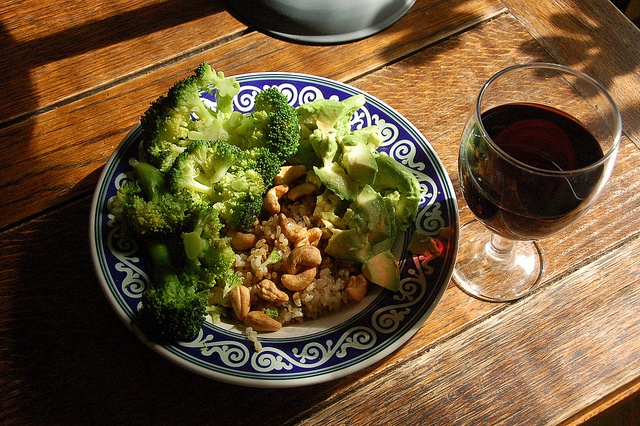Describe the objects in this image and their specific colors. I can see dining table in black, brown, maroon, tan, and olive tones, wine glass in brown, black, tan, maroon, and gray tones, broccoli in brown, black, olive, and darkgreen tones, bowl in brown, black, darkgray, and gray tones, and broccoli in brown, olive, and khaki tones in this image. 